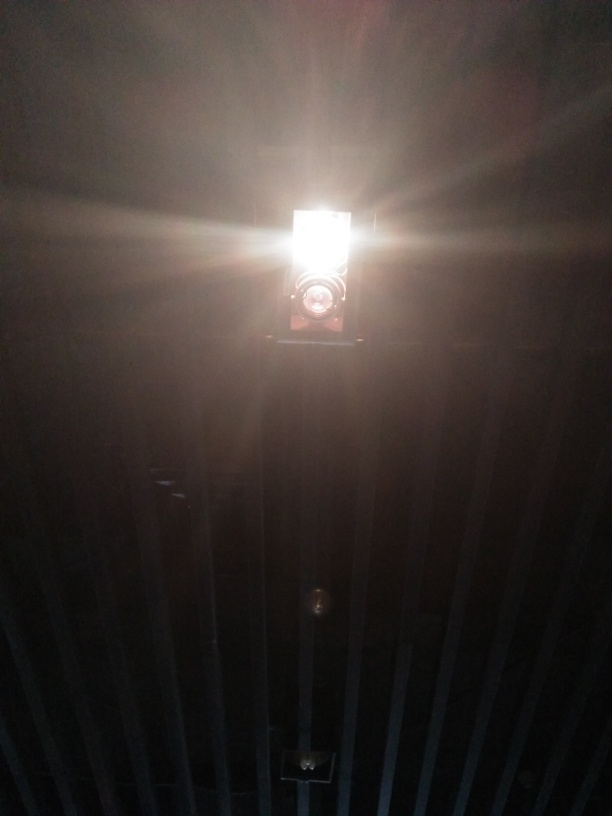Can you infer the time of day this photo was taken? It's challenging to determine the time of day based on the glare and the lack of contextual elements. However, the artificial light suggests it might be taken during the evening or at night when such illumination would be necessary. Could this be an indoor or outdoor setting? Considering the visible structural elements and light fixture, it's more likely to be an indoor setting, perhaps a hallway or a room with a high ceiling. 